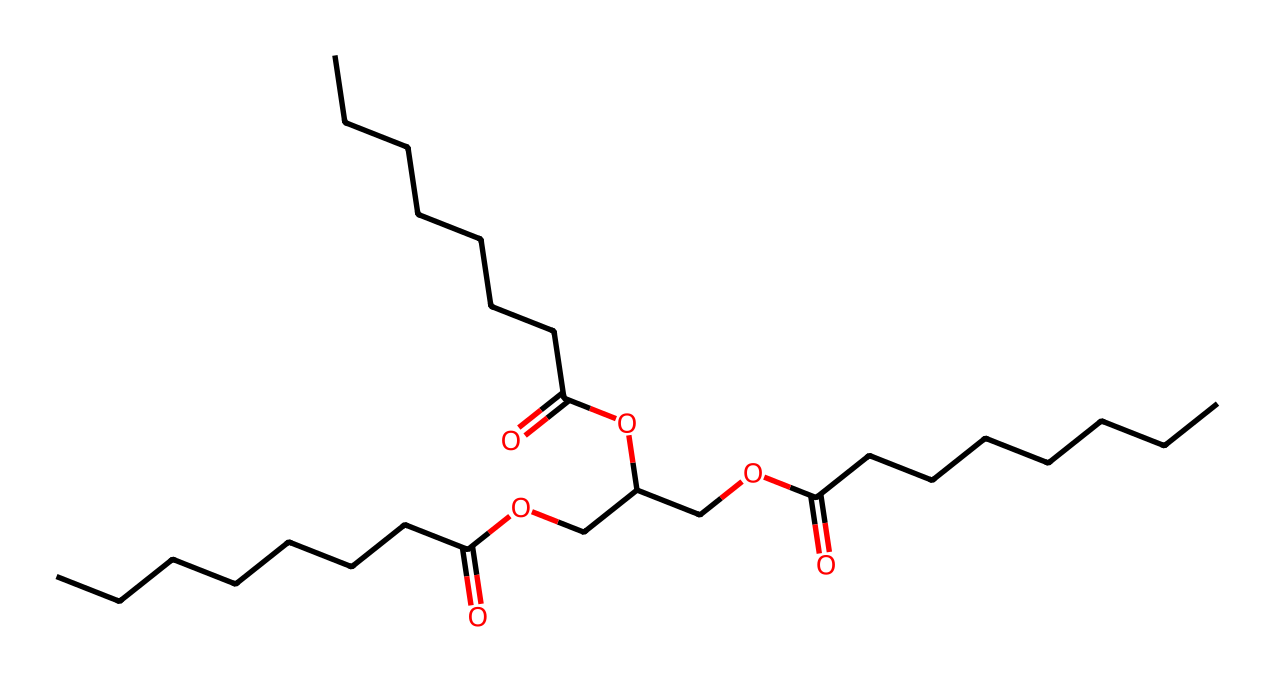What type of lipid is represented in this structure? The structure shows a triglyceride because it consists of a glycerol backbone connected to three fatty acid chains. Triglycerides are the most common form of fat in the body.
Answer: triglyceride How many carbon atoms are in the longest fatty acid chain? By analyzing the structure, the longest fatty acid chain has nine carbon atoms (the straight chain without any branching). This can be deduced from counting the carbon atoms in the longest sequence of C's connected in the SMILES notation.
Answer: nine What is the total number of ester bonds present in this molecule? The molecule includes three ester bonds, which occur where the hydroxyl groups of glycerol react with fatty acids, forming ester linkages. Each fatty acid connected to glycerol contributes one ester bond.
Answer: three What is the functional group present in this molecule? The presence of the -O- (ether) and -C(=O)O- (carboxyl) groups indicated by the structure highlights that this molecule contains ester functional groups, which are characteristic of triglycerides.
Answer: ester How many oxygen atoms are present in the molecule? Counting the symbols shows there are six oxygen atoms in total. Each oxygen atom is part of either the ester groups or hydroxy groups in the triglyceride structure.
Answer: six 